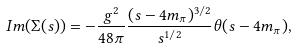Convert formula to latex. <formula><loc_0><loc_0><loc_500><loc_500>I m ( \Sigma ( s ) ) = - \frac { g ^ { 2 } } { 4 8 \pi } \frac { ( s - 4 m _ { \pi } ) ^ { 3 / 2 } } { s ^ { 1 / 2 } } \theta ( s - 4 m _ { \pi } ) ,</formula> 